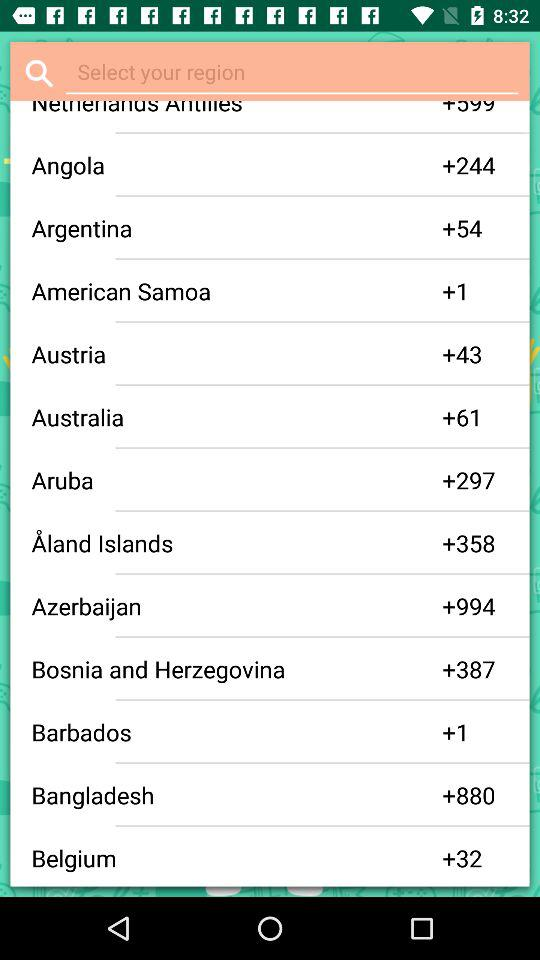What is the Aruba region's code? The Aruba's code is +297. 